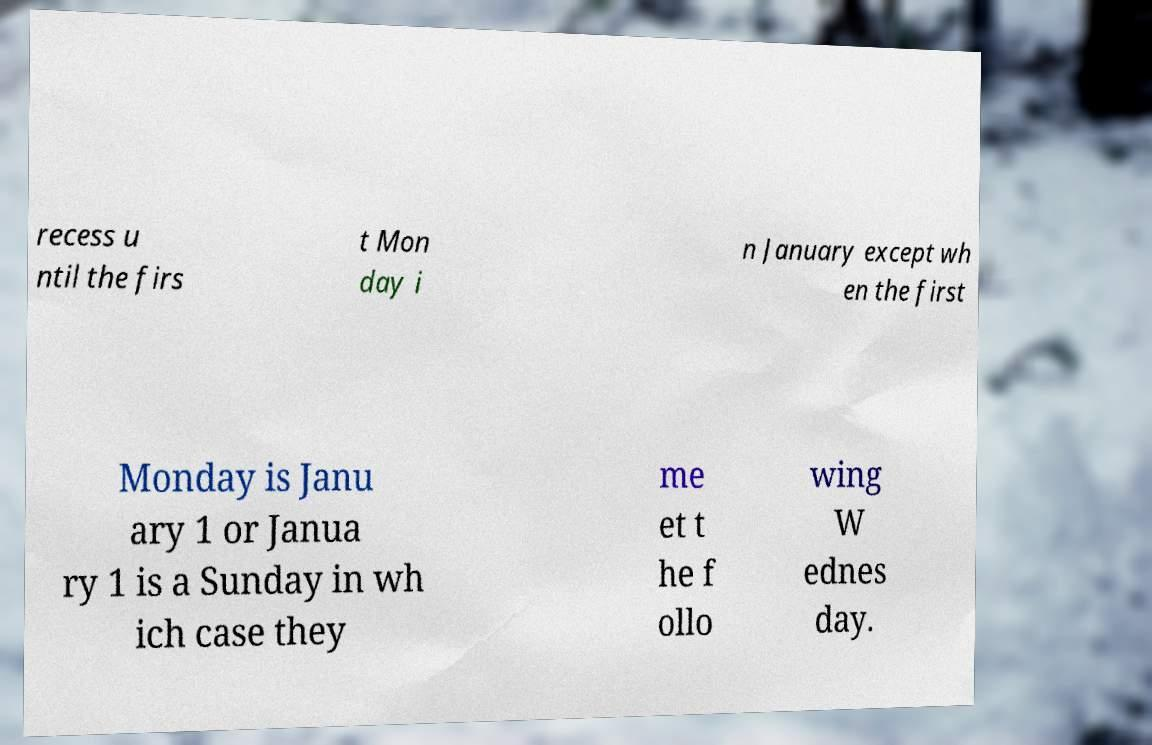Can you accurately transcribe the text from the provided image for me? recess u ntil the firs t Mon day i n January except wh en the first Monday is Janu ary 1 or Janua ry 1 is a Sunday in wh ich case they me et t he f ollo wing W ednes day. 